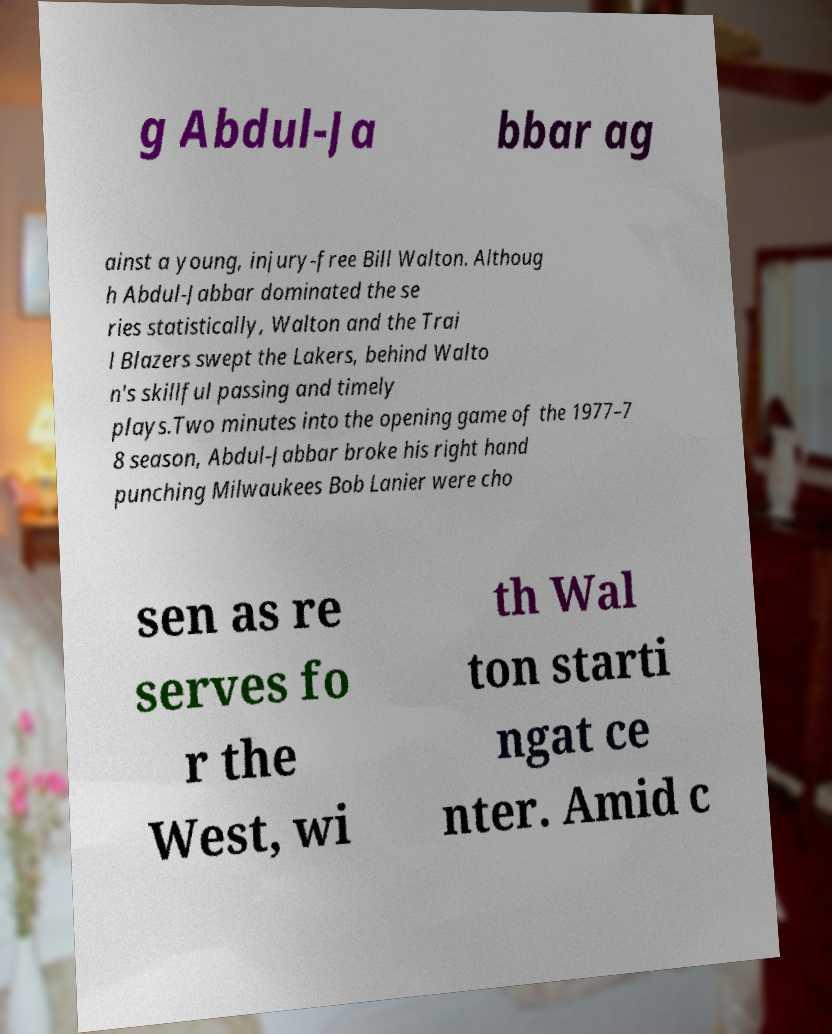Can you accurately transcribe the text from the provided image for me? g Abdul-Ja bbar ag ainst a young, injury-free Bill Walton. Althoug h Abdul-Jabbar dominated the se ries statistically, Walton and the Trai l Blazers swept the Lakers, behind Walto n's skillful passing and timely plays.Two minutes into the opening game of the 1977–7 8 season, Abdul-Jabbar broke his right hand punching Milwaukees Bob Lanier were cho sen as re serves fo r the West, wi th Wal ton starti ngat ce nter. Amid c 